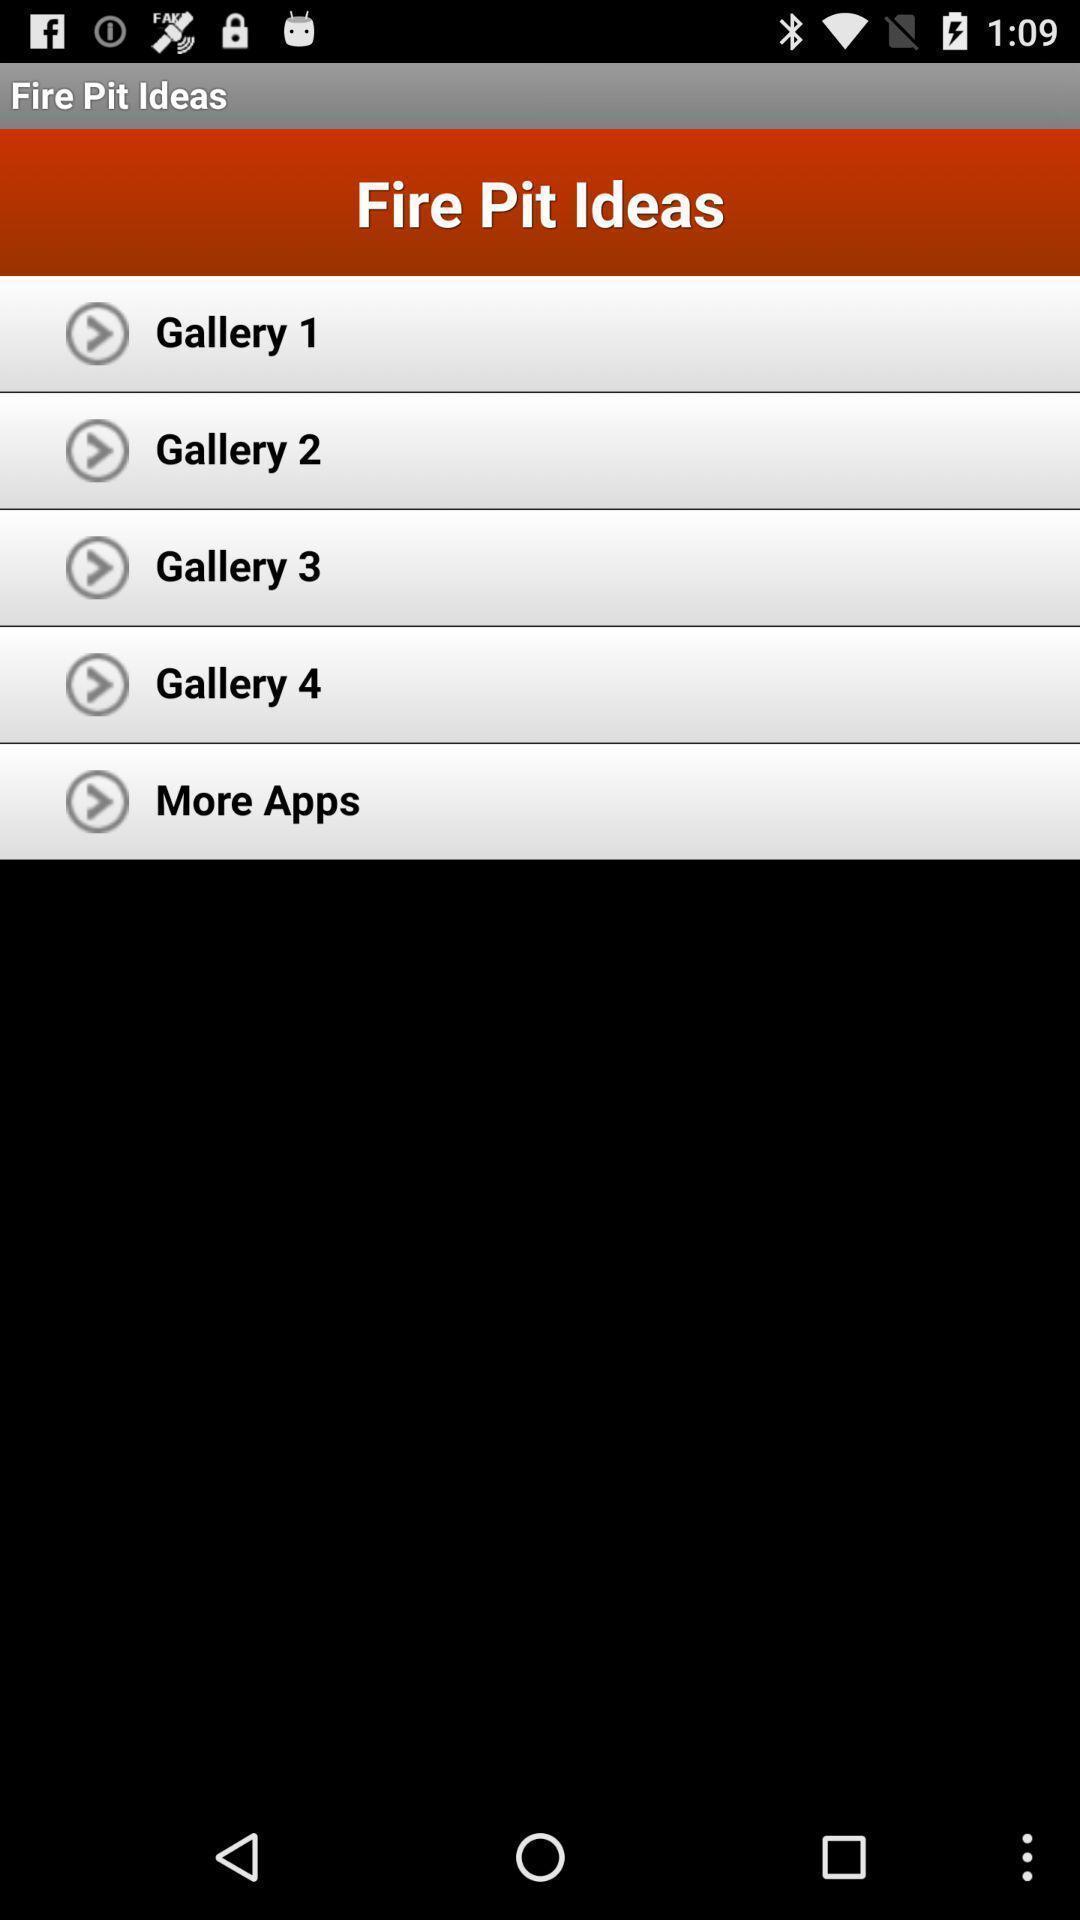Describe the key features of this screenshot. Page displaying with list of idea options. 